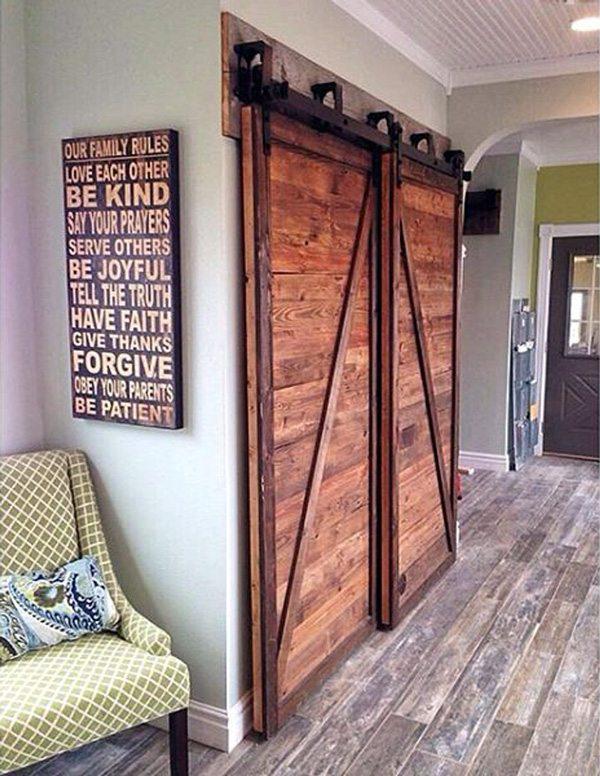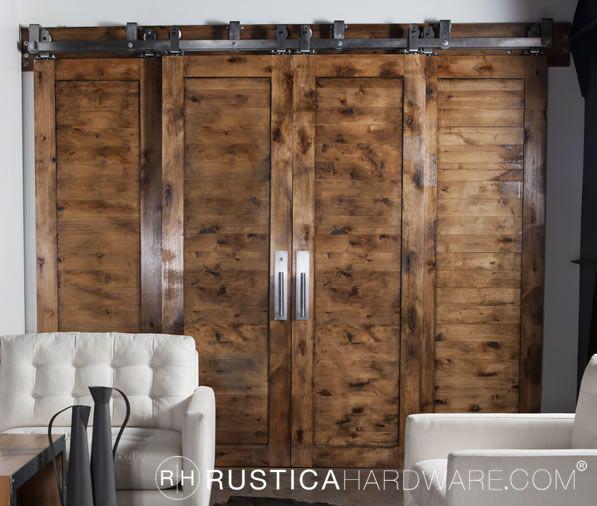The first image is the image on the left, the second image is the image on the right. Analyze the images presented: Is the assertion "A white sliding closet door on overhead bar is standing open." valid? Answer yes or no. No. The first image is the image on the left, the second image is the image on the right. Considering the images on both sides, is "There is a closet white sliding doors in one of the images." valid? Answer yes or no. No. 